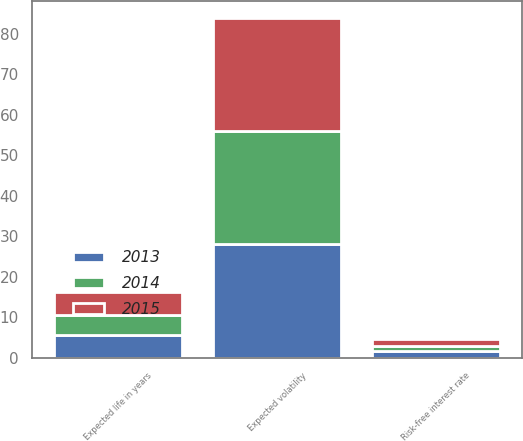Convert chart. <chart><loc_0><loc_0><loc_500><loc_500><stacked_bar_chart><ecel><fcel>Risk-free interest rate<fcel>Expected life in years<fcel>Expected volatility<nl><fcel>2013<fcel>1.65<fcel>5.7<fcel>28<nl><fcel>2015<fcel>1.66<fcel>5.6<fcel>28<nl><fcel>2014<fcel>1.31<fcel>5<fcel>28<nl></chart> 